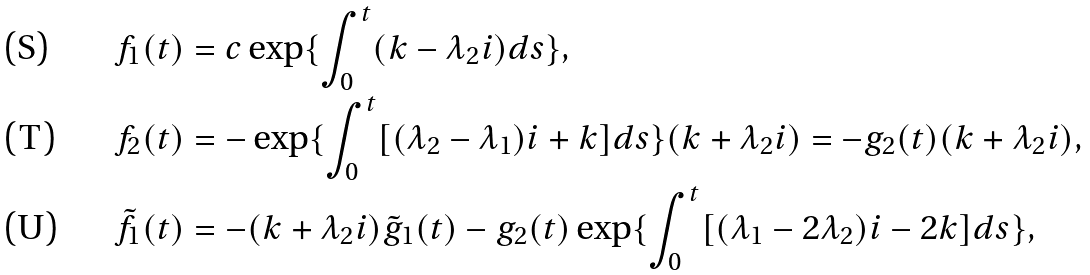<formula> <loc_0><loc_0><loc_500><loc_500>& f _ { 1 } ( t ) = c \exp \{ \int ^ { t } _ { 0 } ( k - \lambda _ { 2 } i ) d s \} , \\ & f _ { 2 } ( t ) = - \exp \{ \int ^ { t } _ { 0 } [ ( \lambda _ { 2 } - \lambda _ { 1 } ) i + k ] d s \} ( k + \lambda _ { 2 } i ) = - g _ { 2 } ( t ) ( k + \lambda _ { 2 } i ) , \\ & \tilde { f } _ { 1 } ( t ) = - ( k + \lambda _ { 2 } i ) \tilde { g } _ { 1 } ( t ) - g _ { 2 } ( t ) \exp \{ \int ^ { t } _ { 0 } [ ( \lambda _ { 1 } - 2 \lambda _ { 2 } ) i - 2 k ] d s \} ,</formula> 